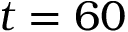<formula> <loc_0><loc_0><loc_500><loc_500>t = 6 0</formula> 